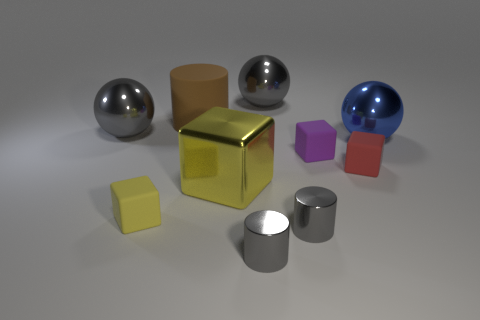Subtract 1 cubes. How many cubes are left? 3 Subtract all cylinders. How many objects are left? 7 Add 5 large gray metallic things. How many large gray metallic things are left? 7 Add 4 large yellow cubes. How many large yellow cubes exist? 5 Subtract 0 brown spheres. How many objects are left? 10 Subtract all gray matte balls. Subtract all purple cubes. How many objects are left? 9 